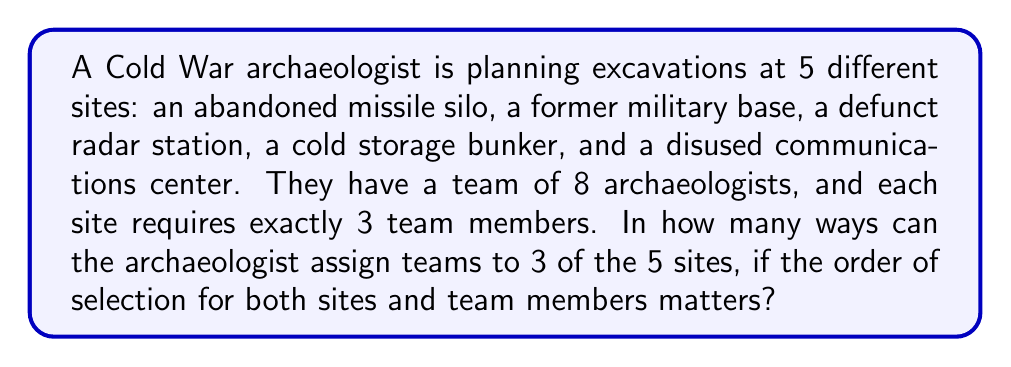Can you answer this question? Let's break this problem down into steps:

1) First, we need to choose 3 sites out of 5. This is a permutation because the order matters. We can calculate this using:
   $$P(5,3) = \frac{5!}{(5-3)!} = \frac{5!}{2!} = 60$$

2) For each of these 60 ways of choosing sites, we need to assign 3 archaeologists to each of the 3 sites.

3) For the first site, we have 8 archaeologists to choose from, and we need to select 3. This is another permutation:
   $$P(8,3) = \frac{8!}{(8-3)!} = \frac{8!}{5!} = 336$$

4) For the second site, we have 5 archaeologists left, and we need to select 3:
   $$P(5,3) = \frac{5!}{(5-3)!} = \frac{5!}{2!} = 60$$

5) For the third site, we have 2 archaeologists left, and we need to select both:
   $$P(2,2) = \frac{2!}{(2-2)!} = 2$$

6) By the multiplication principle, the total number of ways to assign teams to 3 sites is:
   $$60 \times 336 \times 60 \times 2 = 2,419,200$$

Therefore, there are 2,419,200 different ways to assign teams to 3 of the 5 sites.
Answer: 2,419,200 